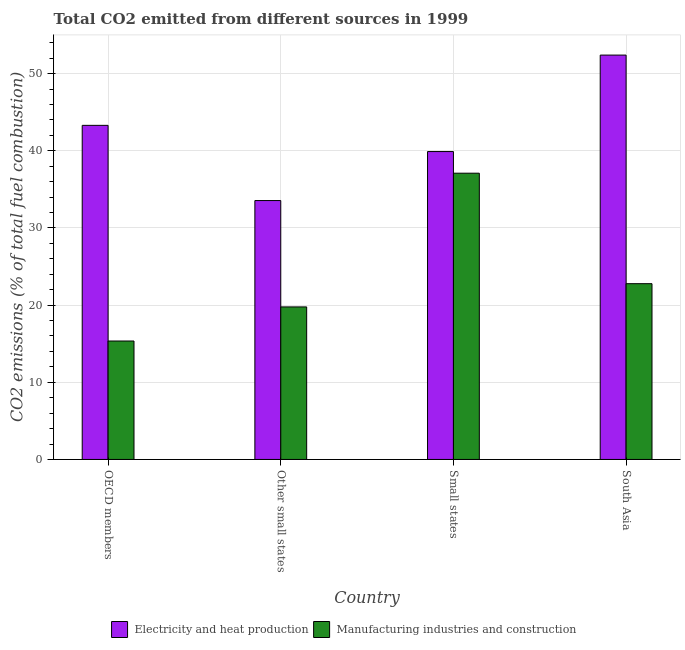Are the number of bars on each tick of the X-axis equal?
Make the answer very short. Yes. What is the label of the 2nd group of bars from the left?
Keep it short and to the point. Other small states. What is the co2 emissions due to electricity and heat production in South Asia?
Give a very brief answer. 52.4. Across all countries, what is the maximum co2 emissions due to electricity and heat production?
Offer a terse response. 52.4. Across all countries, what is the minimum co2 emissions due to manufacturing industries?
Offer a very short reply. 15.35. In which country was the co2 emissions due to manufacturing industries maximum?
Your answer should be very brief. Small states. In which country was the co2 emissions due to manufacturing industries minimum?
Offer a very short reply. OECD members. What is the total co2 emissions due to manufacturing industries in the graph?
Provide a succinct answer. 94.98. What is the difference between the co2 emissions due to manufacturing industries in OECD members and that in Small states?
Make the answer very short. -21.74. What is the difference between the co2 emissions due to electricity and heat production in Small states and the co2 emissions due to manufacturing industries in Other small states?
Ensure brevity in your answer.  20.13. What is the average co2 emissions due to electricity and heat production per country?
Keep it short and to the point. 42.28. What is the difference between the co2 emissions due to manufacturing industries and co2 emissions due to electricity and heat production in Other small states?
Your answer should be compact. -13.78. In how many countries, is the co2 emissions due to manufacturing industries greater than 6 %?
Provide a short and direct response. 4. What is the ratio of the co2 emissions due to manufacturing industries in OECD members to that in Other small states?
Your answer should be very brief. 0.78. Is the co2 emissions due to electricity and heat production in Other small states less than that in South Asia?
Make the answer very short. Yes. What is the difference between the highest and the second highest co2 emissions due to manufacturing industries?
Offer a terse response. 14.31. What is the difference between the highest and the lowest co2 emissions due to manufacturing industries?
Provide a succinct answer. 21.74. In how many countries, is the co2 emissions due to manufacturing industries greater than the average co2 emissions due to manufacturing industries taken over all countries?
Offer a very short reply. 1. What does the 1st bar from the left in Small states represents?
Ensure brevity in your answer.  Electricity and heat production. What does the 1st bar from the right in South Asia represents?
Offer a terse response. Manufacturing industries and construction. What is the difference between two consecutive major ticks on the Y-axis?
Provide a short and direct response. 10. What is the title of the graph?
Provide a succinct answer. Total CO2 emitted from different sources in 1999. Does "Long-term debt" appear as one of the legend labels in the graph?
Provide a succinct answer. No. What is the label or title of the X-axis?
Your answer should be compact. Country. What is the label or title of the Y-axis?
Provide a short and direct response. CO2 emissions (% of total fuel combustion). What is the CO2 emissions (% of total fuel combustion) of Electricity and heat production in OECD members?
Your answer should be compact. 43.29. What is the CO2 emissions (% of total fuel combustion) of Manufacturing industries and construction in OECD members?
Make the answer very short. 15.35. What is the CO2 emissions (% of total fuel combustion) of Electricity and heat production in Other small states?
Provide a short and direct response. 33.55. What is the CO2 emissions (% of total fuel combustion) in Manufacturing industries and construction in Other small states?
Your response must be concise. 19.76. What is the CO2 emissions (% of total fuel combustion) in Electricity and heat production in Small states?
Offer a terse response. 39.9. What is the CO2 emissions (% of total fuel combustion) in Manufacturing industries and construction in Small states?
Offer a very short reply. 37.09. What is the CO2 emissions (% of total fuel combustion) in Electricity and heat production in South Asia?
Offer a very short reply. 52.4. What is the CO2 emissions (% of total fuel combustion) in Manufacturing industries and construction in South Asia?
Your answer should be compact. 22.78. Across all countries, what is the maximum CO2 emissions (% of total fuel combustion) in Electricity and heat production?
Provide a succinct answer. 52.4. Across all countries, what is the maximum CO2 emissions (% of total fuel combustion) in Manufacturing industries and construction?
Provide a succinct answer. 37.09. Across all countries, what is the minimum CO2 emissions (% of total fuel combustion) in Electricity and heat production?
Offer a terse response. 33.55. Across all countries, what is the minimum CO2 emissions (% of total fuel combustion) of Manufacturing industries and construction?
Offer a very short reply. 15.35. What is the total CO2 emissions (% of total fuel combustion) in Electricity and heat production in the graph?
Make the answer very short. 169.13. What is the total CO2 emissions (% of total fuel combustion) in Manufacturing industries and construction in the graph?
Provide a short and direct response. 94.98. What is the difference between the CO2 emissions (% of total fuel combustion) in Electricity and heat production in OECD members and that in Other small states?
Make the answer very short. 9.74. What is the difference between the CO2 emissions (% of total fuel combustion) in Manufacturing industries and construction in OECD members and that in Other small states?
Keep it short and to the point. -4.42. What is the difference between the CO2 emissions (% of total fuel combustion) in Electricity and heat production in OECD members and that in Small states?
Give a very brief answer. 3.4. What is the difference between the CO2 emissions (% of total fuel combustion) of Manufacturing industries and construction in OECD members and that in Small states?
Your answer should be compact. -21.74. What is the difference between the CO2 emissions (% of total fuel combustion) in Electricity and heat production in OECD members and that in South Asia?
Your answer should be very brief. -9.1. What is the difference between the CO2 emissions (% of total fuel combustion) of Manufacturing industries and construction in OECD members and that in South Asia?
Keep it short and to the point. -7.43. What is the difference between the CO2 emissions (% of total fuel combustion) in Electricity and heat production in Other small states and that in Small states?
Provide a short and direct response. -6.35. What is the difference between the CO2 emissions (% of total fuel combustion) in Manufacturing industries and construction in Other small states and that in Small states?
Offer a terse response. -17.33. What is the difference between the CO2 emissions (% of total fuel combustion) of Electricity and heat production in Other small states and that in South Asia?
Ensure brevity in your answer.  -18.85. What is the difference between the CO2 emissions (% of total fuel combustion) in Manufacturing industries and construction in Other small states and that in South Asia?
Offer a very short reply. -3.01. What is the difference between the CO2 emissions (% of total fuel combustion) in Electricity and heat production in Small states and that in South Asia?
Your answer should be compact. -12.5. What is the difference between the CO2 emissions (% of total fuel combustion) in Manufacturing industries and construction in Small states and that in South Asia?
Offer a terse response. 14.31. What is the difference between the CO2 emissions (% of total fuel combustion) of Electricity and heat production in OECD members and the CO2 emissions (% of total fuel combustion) of Manufacturing industries and construction in Other small states?
Your answer should be very brief. 23.53. What is the difference between the CO2 emissions (% of total fuel combustion) of Electricity and heat production in OECD members and the CO2 emissions (% of total fuel combustion) of Manufacturing industries and construction in Small states?
Keep it short and to the point. 6.2. What is the difference between the CO2 emissions (% of total fuel combustion) in Electricity and heat production in OECD members and the CO2 emissions (% of total fuel combustion) in Manufacturing industries and construction in South Asia?
Provide a succinct answer. 20.51. What is the difference between the CO2 emissions (% of total fuel combustion) of Electricity and heat production in Other small states and the CO2 emissions (% of total fuel combustion) of Manufacturing industries and construction in Small states?
Your answer should be very brief. -3.54. What is the difference between the CO2 emissions (% of total fuel combustion) of Electricity and heat production in Other small states and the CO2 emissions (% of total fuel combustion) of Manufacturing industries and construction in South Asia?
Your answer should be compact. 10.77. What is the difference between the CO2 emissions (% of total fuel combustion) of Electricity and heat production in Small states and the CO2 emissions (% of total fuel combustion) of Manufacturing industries and construction in South Asia?
Make the answer very short. 17.12. What is the average CO2 emissions (% of total fuel combustion) of Electricity and heat production per country?
Make the answer very short. 42.28. What is the average CO2 emissions (% of total fuel combustion) of Manufacturing industries and construction per country?
Offer a very short reply. 23.74. What is the difference between the CO2 emissions (% of total fuel combustion) in Electricity and heat production and CO2 emissions (% of total fuel combustion) in Manufacturing industries and construction in OECD members?
Ensure brevity in your answer.  27.94. What is the difference between the CO2 emissions (% of total fuel combustion) of Electricity and heat production and CO2 emissions (% of total fuel combustion) of Manufacturing industries and construction in Other small states?
Ensure brevity in your answer.  13.78. What is the difference between the CO2 emissions (% of total fuel combustion) in Electricity and heat production and CO2 emissions (% of total fuel combustion) in Manufacturing industries and construction in Small states?
Offer a very short reply. 2.8. What is the difference between the CO2 emissions (% of total fuel combustion) of Electricity and heat production and CO2 emissions (% of total fuel combustion) of Manufacturing industries and construction in South Asia?
Offer a very short reply. 29.62. What is the ratio of the CO2 emissions (% of total fuel combustion) in Electricity and heat production in OECD members to that in Other small states?
Offer a terse response. 1.29. What is the ratio of the CO2 emissions (% of total fuel combustion) of Manufacturing industries and construction in OECD members to that in Other small states?
Your response must be concise. 0.78. What is the ratio of the CO2 emissions (% of total fuel combustion) in Electricity and heat production in OECD members to that in Small states?
Your response must be concise. 1.09. What is the ratio of the CO2 emissions (% of total fuel combustion) in Manufacturing industries and construction in OECD members to that in Small states?
Your answer should be very brief. 0.41. What is the ratio of the CO2 emissions (% of total fuel combustion) in Electricity and heat production in OECD members to that in South Asia?
Ensure brevity in your answer.  0.83. What is the ratio of the CO2 emissions (% of total fuel combustion) of Manufacturing industries and construction in OECD members to that in South Asia?
Make the answer very short. 0.67. What is the ratio of the CO2 emissions (% of total fuel combustion) of Electricity and heat production in Other small states to that in Small states?
Provide a short and direct response. 0.84. What is the ratio of the CO2 emissions (% of total fuel combustion) in Manufacturing industries and construction in Other small states to that in Small states?
Ensure brevity in your answer.  0.53. What is the ratio of the CO2 emissions (% of total fuel combustion) of Electricity and heat production in Other small states to that in South Asia?
Make the answer very short. 0.64. What is the ratio of the CO2 emissions (% of total fuel combustion) in Manufacturing industries and construction in Other small states to that in South Asia?
Offer a very short reply. 0.87. What is the ratio of the CO2 emissions (% of total fuel combustion) in Electricity and heat production in Small states to that in South Asia?
Provide a short and direct response. 0.76. What is the ratio of the CO2 emissions (% of total fuel combustion) in Manufacturing industries and construction in Small states to that in South Asia?
Your response must be concise. 1.63. What is the difference between the highest and the second highest CO2 emissions (% of total fuel combustion) in Electricity and heat production?
Your response must be concise. 9.1. What is the difference between the highest and the second highest CO2 emissions (% of total fuel combustion) of Manufacturing industries and construction?
Provide a succinct answer. 14.31. What is the difference between the highest and the lowest CO2 emissions (% of total fuel combustion) in Electricity and heat production?
Offer a terse response. 18.85. What is the difference between the highest and the lowest CO2 emissions (% of total fuel combustion) of Manufacturing industries and construction?
Provide a succinct answer. 21.74. 